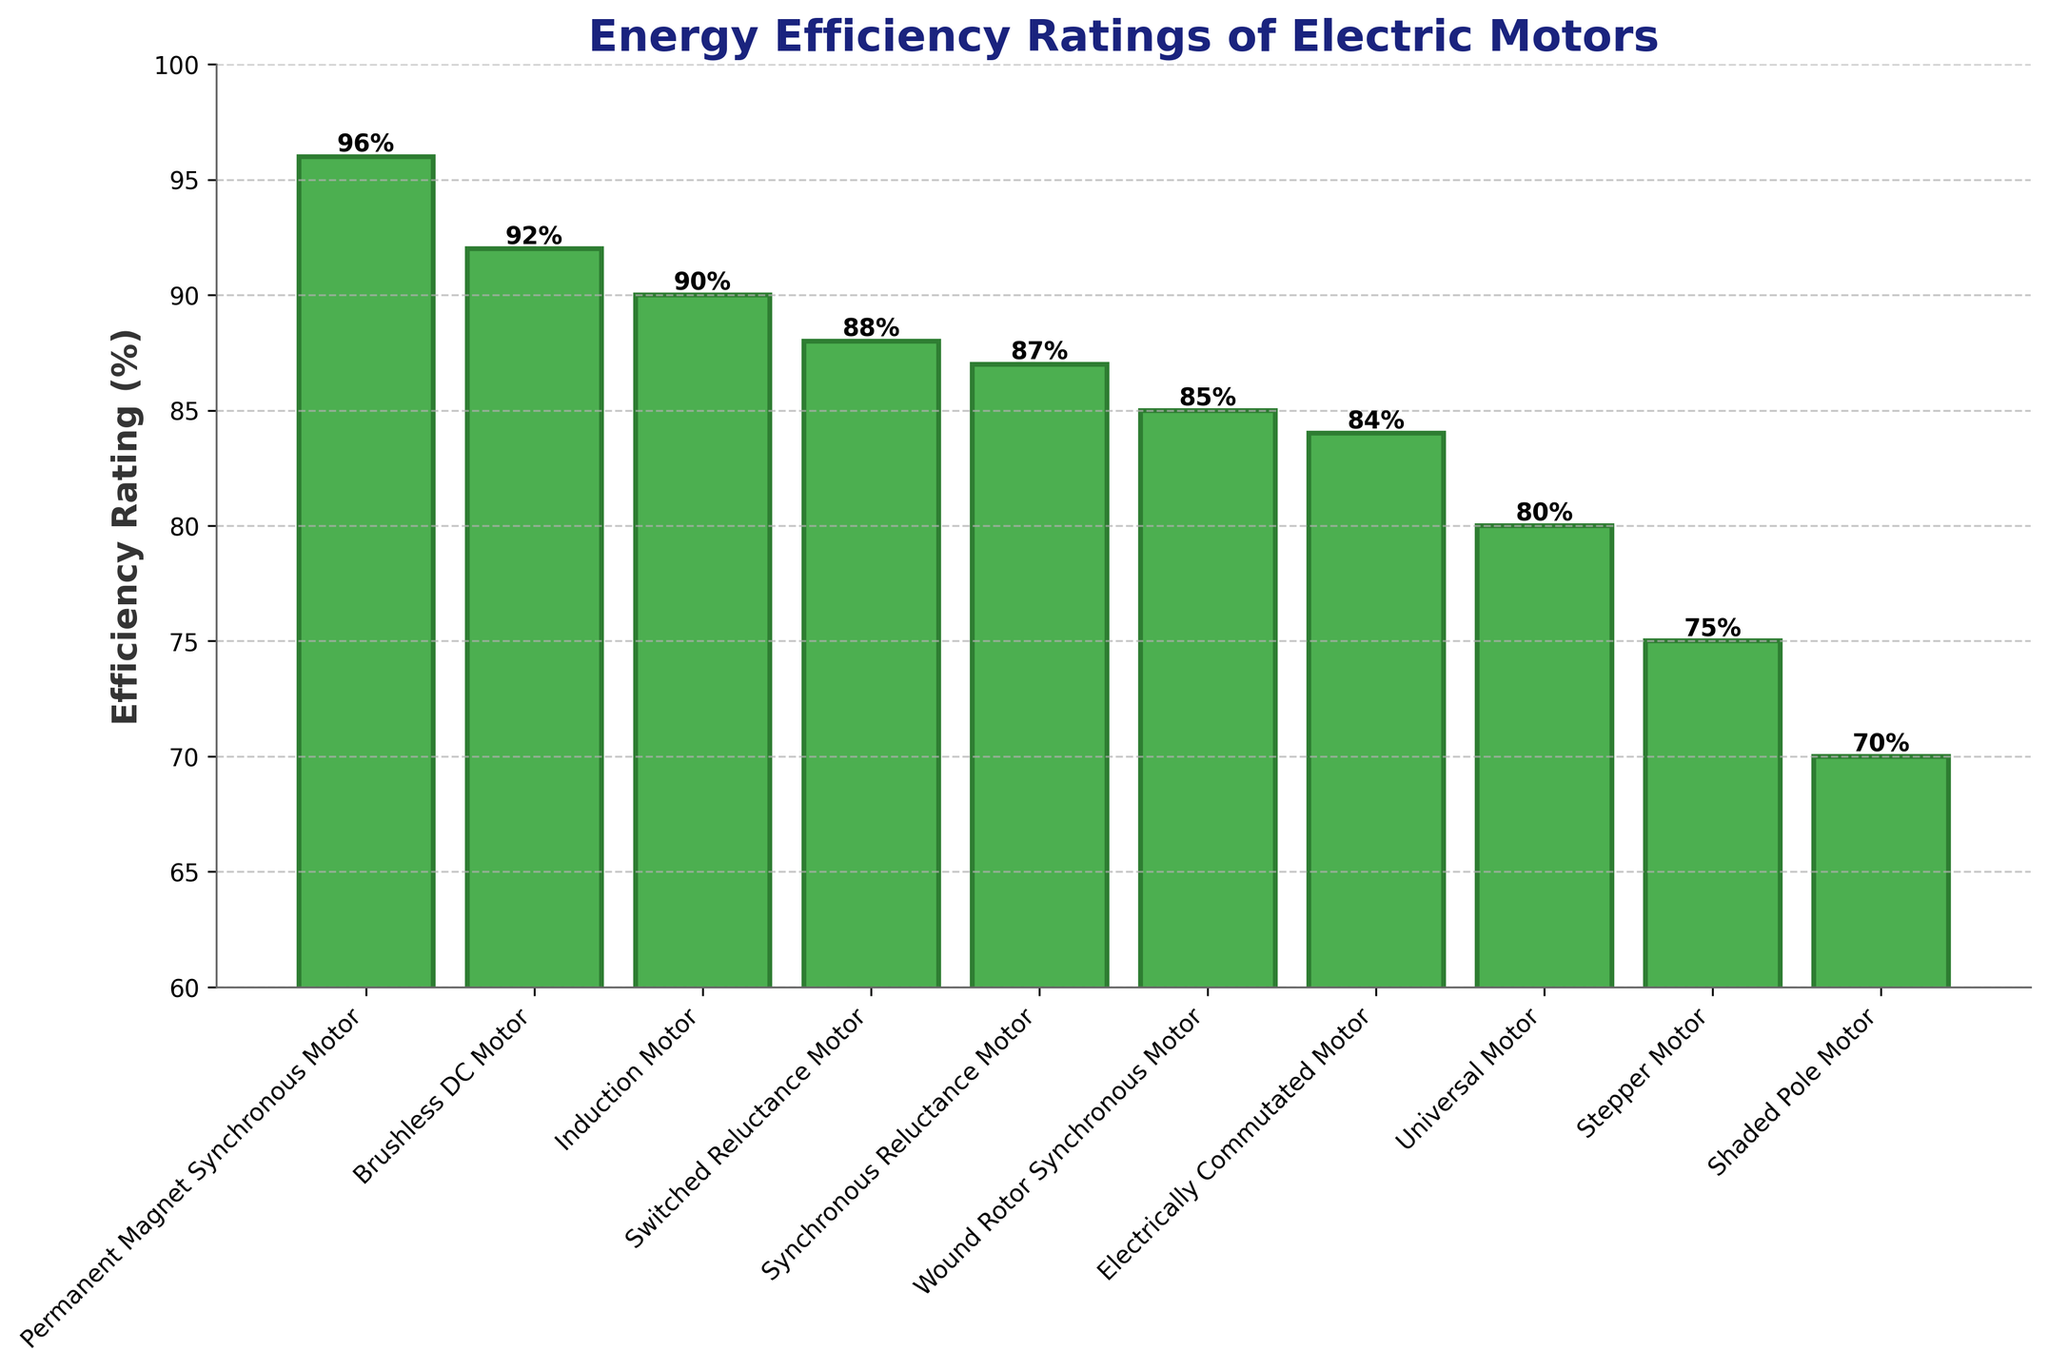Which motor has the highest efficiency rating? The highest bar represents the motor with the highest efficiency rating. The bar for the Permanent Magnet Synchronous Motor is the tallest, indicating it has the highest efficiency rating of 96%.
Answer: Permanent Magnet Synchronous Motor Which motor has the lowest efficiency rating? The lowest bar represents the motor with the lowest efficiency rating. The bar for the Shaded Pole Motor is the shortest, indicating it has the lowest efficiency rating of 70%.
Answer: Shaded Pole Motor How much higher is the efficiency rating of the Permanent Magnet Synchronous Motor compared to the Universal Motor? The efficiency rating of the Permanent Magnet Synchronous Motor is 96%, and that of the Universal Motor is 80%. Subtract the latter from the former: 96% - 80% = 16%.
Answer: 16% Which motor types have efficiency ratings greater than 90%? Look for bars that extend above the 90% mark. The motors fitting this criterion are Permanent Magnet Synchronous Motor (96%) and Brushless DC Motor (92%).
Answer: Permanent Magnet Synchronous Motor, Brushless DC Motor What is the average efficiency rating of all listed motors? Calculate the sum of all efficiency ratings and divide by the number of motor types. Sum = 96 + 92 + 90 + 88 + 87 + 85 + 84 + 80 + 75 + 70 = 847. Number of motor types = 10. Average = 847 / 10 = 84.7%.
Answer: 84.7% What is the median efficiency rating of the motors? Arrange the efficiency ratings in ascending order: 70, 75, 80, 84, 85, 87, 88, 90, 92, 96. The median is the average of the 5th and 6th values: (85 + 87) / 2 = 86%.
Answer: 86% Which motor types have efficiency ratings between 80% and 85%, inclusive? Identify bars whose heights represent values in the range of 80% to 85%. These include Electrically Commutated Motor (84%) and Universal Motor (80%).
Answer: Electrically Commutated Motor, Universal Motor How does the efficiency rating of the Induction Motor compare to that of the Wound Rotor Synchronous Motor? The efficiency rating of the Induction Motor is 90%, while the Wound Rotor Synchronous Motor is 85%. The Induction Motor has a higher efficiency rating by 90% - 85% = 5%.
Answer: Induction Motor is higher by 5% How many motor types have efficiency ratings below 85%? Count the number of bars that represent values below 85%. These include Universal Motor (80%), Stepper Motor (75%), and Shaded Pole Motor (70%), totaling three.
Answer: 3 